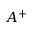<formula> <loc_0><loc_0><loc_500><loc_500>A ^ { + }</formula> 